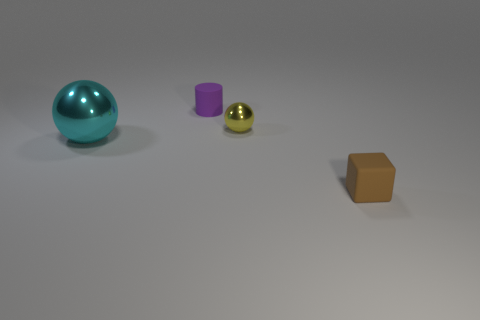Imagine these objects are part of a game, what could be the rules involving them? This could be a sorting game where players must categorize objects by material, size, or color. For instance, spheres must be placed in one zone, cylinders in another, and cubes in a third, with bonus points for grouping by color or placing them in order from largest to smallest. 